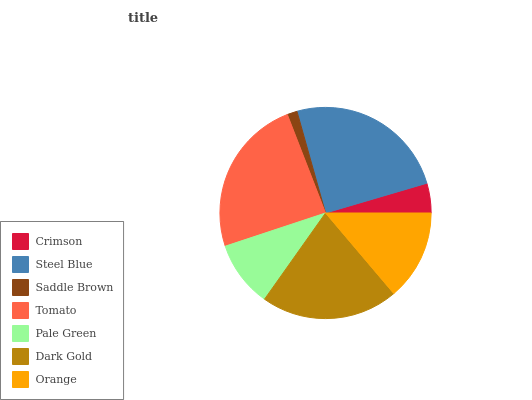Is Saddle Brown the minimum?
Answer yes or no. Yes. Is Steel Blue the maximum?
Answer yes or no. Yes. Is Steel Blue the minimum?
Answer yes or no. No. Is Saddle Brown the maximum?
Answer yes or no. No. Is Steel Blue greater than Saddle Brown?
Answer yes or no. Yes. Is Saddle Brown less than Steel Blue?
Answer yes or no. Yes. Is Saddle Brown greater than Steel Blue?
Answer yes or no. No. Is Steel Blue less than Saddle Brown?
Answer yes or no. No. Is Orange the high median?
Answer yes or no. Yes. Is Orange the low median?
Answer yes or no. Yes. Is Crimson the high median?
Answer yes or no. No. Is Saddle Brown the low median?
Answer yes or no. No. 